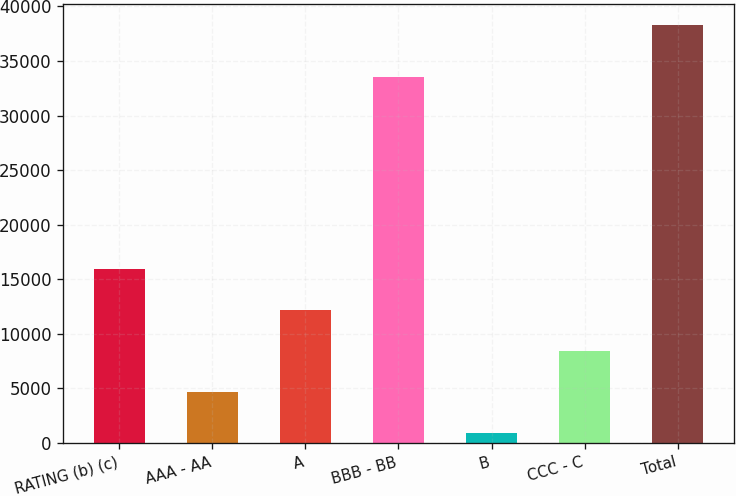Convert chart to OTSL. <chart><loc_0><loc_0><loc_500><loc_500><bar_chart><fcel>RATING (b) (c)<fcel>AAA - AA<fcel>A<fcel>BBB - BB<fcel>B<fcel>CCC - C<fcel>Total<nl><fcel>15901.6<fcel>4689.4<fcel>12164.2<fcel>33497<fcel>952<fcel>8426.8<fcel>38326<nl></chart> 